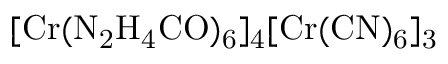<formula> <loc_0><loc_0><loc_500><loc_500>[ C r ( N _ { 2 } H _ { 4 } C O ) _ { 6 } ] _ { 4 } [ C r ( C N ) _ { 6 } ] _ { 3 }</formula> 